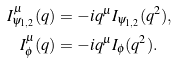<formula> <loc_0><loc_0><loc_500><loc_500>I ^ { \mu } _ { \psi _ { 1 , 2 } } ( q ) & = - i q ^ { \mu } I _ { \psi _ { 1 , 2 } } ( q ^ { 2 } ) , \\ I ^ { \mu } _ { \phi } ( q ) & = - i q ^ { \mu } I _ { \phi } ( q ^ { 2 } ) .</formula> 